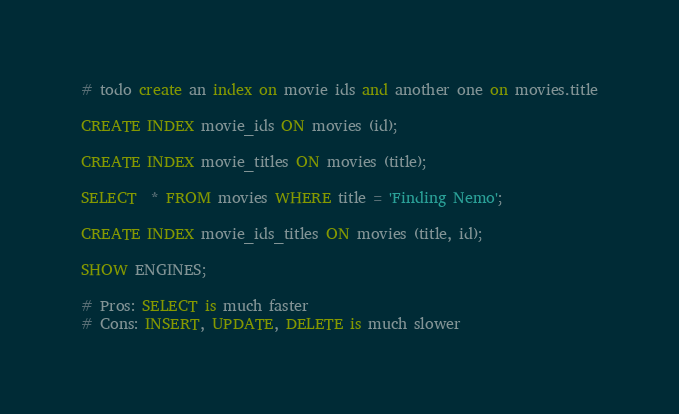Convert code to text. <code><loc_0><loc_0><loc_500><loc_500><_SQL_># todo create an index on movie ids and another one on movies.title

CREATE INDEX movie_ids ON movies (id);

CREATE INDEX movie_titles ON movies (title);

SELECT  * FROM movies WHERE title = 'Finding Nemo';

CREATE INDEX movie_ids_titles ON movies (title, id);

SHOW ENGINES;

# Pros: SELECT is much faster
# Cons: INSERT, UPDATE, DELETE is much slower</code> 